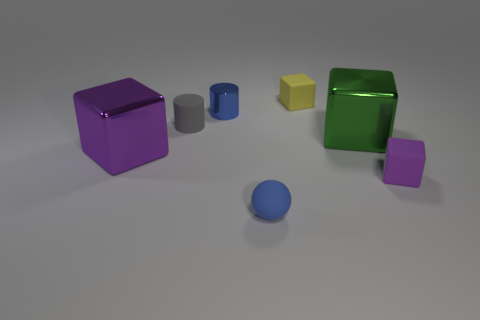Subtract all yellow cubes. How many cubes are left? 3 Add 2 tiny green metal cubes. How many objects exist? 9 Subtract all blue cylinders. How many cylinders are left? 1 Subtract all purple cylinders. How many purple blocks are left? 2 Subtract 1 balls. How many balls are left? 0 Subtract all spheres. How many objects are left? 6 Subtract all green cylinders. Subtract all green blocks. How many cylinders are left? 2 Subtract all tiny metal cubes. Subtract all blue matte objects. How many objects are left? 6 Add 3 matte things. How many matte things are left? 7 Add 3 big yellow cylinders. How many big yellow cylinders exist? 3 